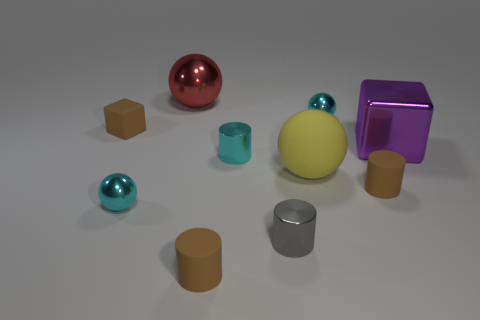Subtract all yellow rubber spheres. How many spheres are left? 3 Subtract 3 cylinders. How many cylinders are left? 1 Subtract all blue spheres. How many green cylinders are left? 0 Subtract all brown matte cylinders. Subtract all big purple metallic blocks. How many objects are left? 7 Add 2 shiny objects. How many shiny objects are left? 8 Add 6 big brown matte balls. How many big brown matte balls exist? 6 Subtract all brown blocks. How many blocks are left? 1 Subtract 2 cyan spheres. How many objects are left? 8 Subtract all cylinders. How many objects are left? 6 Subtract all brown cylinders. Subtract all gray cubes. How many cylinders are left? 2 